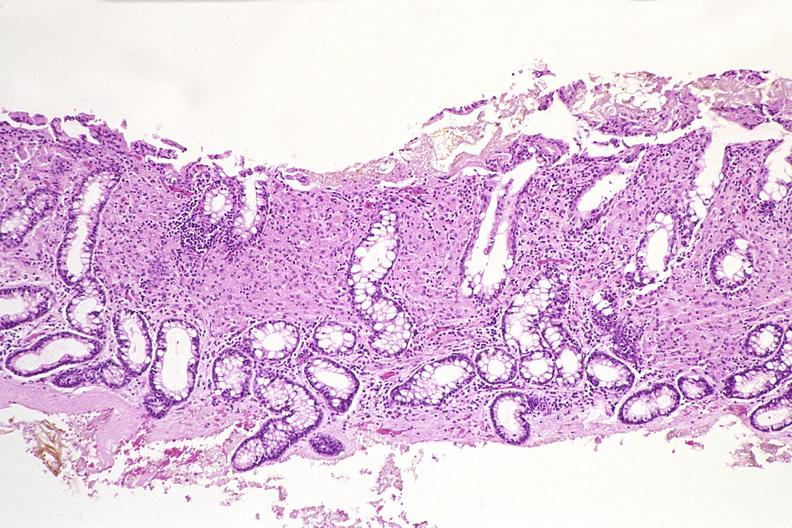where is this from?
Answer the question using a single word or phrase. Gastrointestinal system 